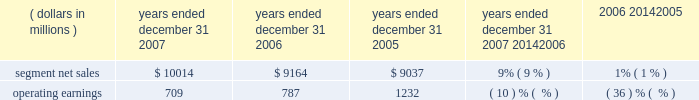Unit shipments increased 49% ( 49 % ) to 217.4 million units in 2006 , compared to 146.0 million units in 2005 .
The overall increase was driven by increased unit shipments of products for gsm , cdma and 3g technologies , partially offset by decreased unit shipments of products for iden technology .
For the full year 2006 , unit shipments by the segment increased in all regions .
Due to the segment 2019s increase in unit shipments outpacing overall growth in the worldwide handset market , which grew approximately 20% ( 20 % ) in 2006 , the segment believes that it expanded its global handset market share to an estimated 22% ( 22 % ) for the full year 2006 .
In 2006 , asp decreased approximately 11% ( 11 % ) compared to 2005 .
The overall decrease in asp was driven primarily by changes in the geographic and product-tier mix of sales .
By comparison , asp decreased approximately 10% ( 10 % ) in 2005 and increased approximately 15% ( 15 % ) in 2004 .
Asp is impacted by numerous factors , including product mix , market conditions and competitive product offerings , and asp trends often vary over time .
In 2006 , the largest of the segment 2019s end customers ( including sales through distributors ) were china mobile , verizon , sprint nextel , cingular , and t-mobile .
These five largest customers accounted for approximately 39% ( 39 % ) of the segment 2019s net sales in 2006 .
Besides selling directly to carriers and operators , the segment also sold products through a variety of third-party distributors and retailers , which accounted for approximately 38% ( 38 % ) of the segment 2019s net sales .
The largest of these distributors was brightstar corporation .
Although the u.s .
Market continued to be the segment 2019s largest individual market , many of our customers , and more than 65% ( 65 % ) of the segment 2019s 2006 net sales , were outside the u.s .
The largest of these international markets were china , brazil , the united kingdom and mexico .
Home and networks mobility segment the home and networks mobility segment designs , manufactures , sells , installs and services : ( i ) digital video , internet protocol ( 201cip 201d ) video and broadcast network interactive set-tops ( 201cdigital entertainment devices 201d ) , end-to- end video delivery solutions , broadband access infrastructure systems , and associated data and voice customer premise equipment ( 201cbroadband gateways 201d ) to cable television and telecom service providers ( collectively , referred to as the 201chome business 201d ) , and ( ii ) wireless access systems ( 201cwireless networks 201d ) , including cellular infrastructure systems and wireless broadband systems , to wireless service providers .
In 2007 , the segment 2019s net sales represented 27% ( 27 % ) of the company 2019s consolidated net sales , compared to 21% ( 21 % ) in 2006 and 26% ( 26 % ) in 2005 .
( dollars in millions ) 2007 2006 2005 2007 20142006 2006 20142005 years ended december 31 percent change .
Segment results 20142007 compared to 2006 in 2007 , the segment 2019s net sales increased 9% ( 9 % ) to $ 10.0 billion , compared to $ 9.2 billion in 2006 .
The 9% ( 9 % ) increase in net sales reflects a 27% ( 27 % ) increase in net sales in the home business , partially offset by a 1% ( 1 % ) decrease in net sales of wireless networks .
Net sales of digital entertainment devices increased approximately 43% ( 43 % ) , reflecting increased demand for digital set-tops , including hd/dvr set-tops and ip set-tops , partially offset by a decline in asp due to a product mix shift towards all-digital set-tops .
Unit shipments of digital entertainment devices increased 51% ( 51 % ) to 15.2 million units .
Net sales of broadband gateways increased approximately 6% ( 6 % ) , primarily due to higher net sales of data modems , driven by net sales from the netopia business acquired in february 2007 .
Net sales of wireless networks decreased 1% ( 1 % ) , primarily driven by lower net sales of iden and cdma infrastructure equipment , partially offset by higher net sales of gsm infrastructure equipment , despite competitive pricing pressure .
On a geographic basis , the 9% ( 9 % ) increase in net sales reflects higher net sales in all geographic regions .
The increase in net sales in north america was driven primarily by higher sales of digital entertainment devices , partially offset by lower net sales of iden and cdma infrastructure equipment .
The increase in net sales in asia was primarily due to higher net sales of gsm infrastructure equipment , partially offset by lower net sales of cdma infrastructure equipment .
The increase in net sales in emea was , primarily due to higher net sales of gsm infrastructure equipment , partially offset by lower demand for iden and cdma infrastructure equipment .
Net sales in north america continue to comprise a significant portion of the segment 2019s business , accounting for 52% ( 52 % ) of the segment 2019s total net sales in 2007 , compared to 56% ( 56 % ) of the segment 2019s total net sales in 2006 .
60 management 2019s discussion and analysis of financial condition and results of operations .
How much segmented net sales was earned in the north america in 2007? 
Rationale: in line 29 , it explains that 52% of segmented net sales was done in north america in 2007 . to find out how much net sales was created in north america we must multiple 52% by the 2007 segmented net sales . this then gives us $ 5207.3
Computations: (10014 * 52%)
Answer: 5207.28. 